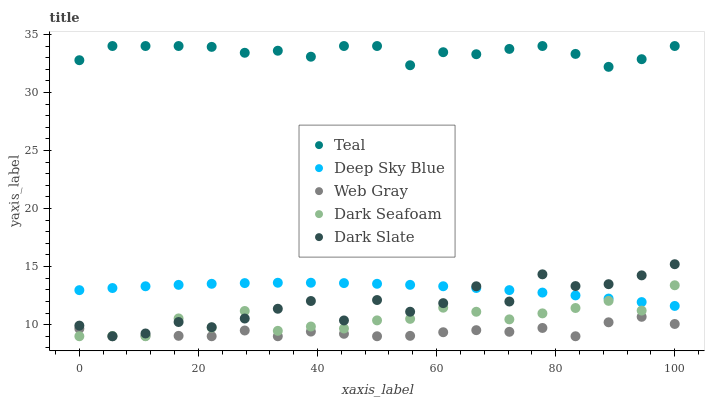Does Web Gray have the minimum area under the curve?
Answer yes or no. Yes. Does Teal have the maximum area under the curve?
Answer yes or no. Yes. Does Dark Seafoam have the minimum area under the curve?
Answer yes or no. No. Does Dark Seafoam have the maximum area under the curve?
Answer yes or no. No. Is Deep Sky Blue the smoothest?
Answer yes or no. Yes. Is Dark Slate the roughest?
Answer yes or no. Yes. Is Dark Seafoam the smoothest?
Answer yes or no. No. Is Dark Seafoam the roughest?
Answer yes or no. No. Does Dark Slate have the lowest value?
Answer yes or no. Yes. Does Deep Sky Blue have the lowest value?
Answer yes or no. No. Does Teal have the highest value?
Answer yes or no. Yes. Does Dark Seafoam have the highest value?
Answer yes or no. No. Is Dark Slate less than Teal?
Answer yes or no. Yes. Is Teal greater than Dark Slate?
Answer yes or no. Yes. Does Dark Seafoam intersect Deep Sky Blue?
Answer yes or no. Yes. Is Dark Seafoam less than Deep Sky Blue?
Answer yes or no. No. Is Dark Seafoam greater than Deep Sky Blue?
Answer yes or no. No. Does Dark Slate intersect Teal?
Answer yes or no. No. 